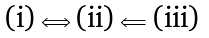Convert formula to latex. <formula><loc_0><loc_0><loc_500><loc_500>\text {(i)} \Longleftrightarrow \text {(ii)} \Longleftarrow \text {(iii)}</formula> 